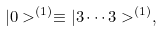<formula> <loc_0><loc_0><loc_500><loc_500>| 0 > ^ { ( 1 ) } \equiv | 3 \cdots 3 > ^ { ( 1 ) } ,</formula> 